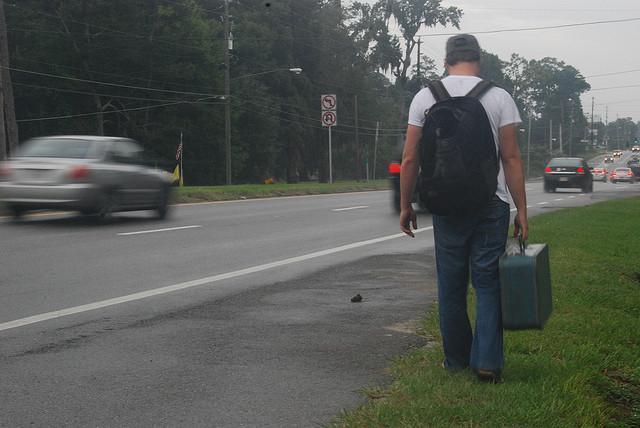How many horses are there?
Give a very brief answer. 0. 